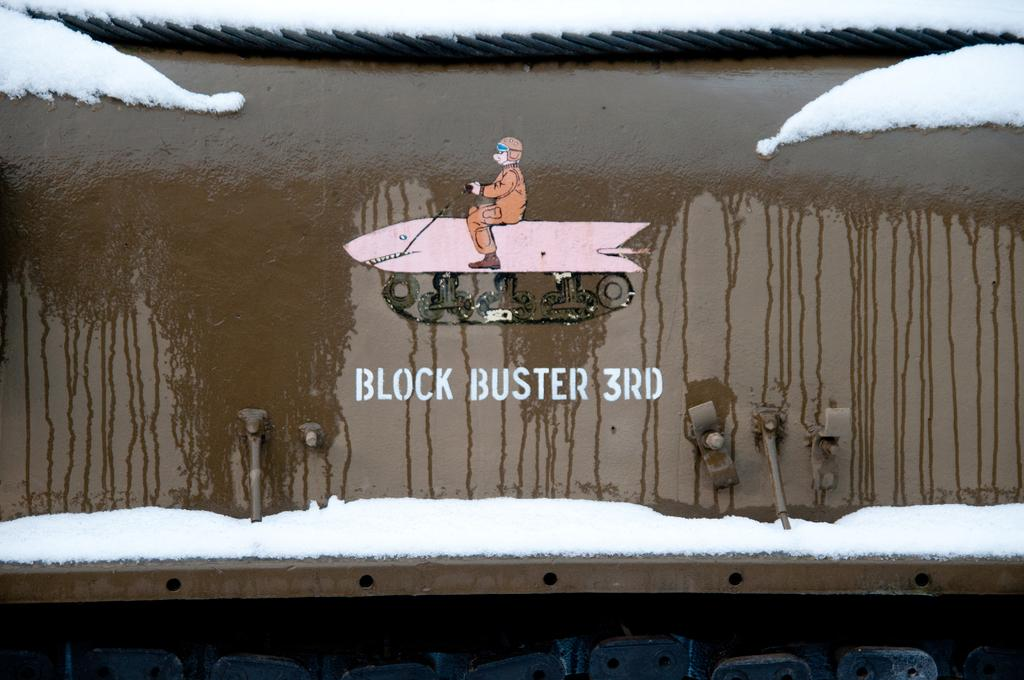<image>
Give a short and clear explanation of the subsequent image. The words "BLOCK BUSTER 3RD" are under a picture of a man on a shark. 